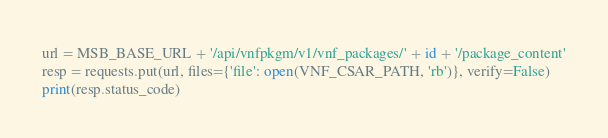Convert code to text. <code><loc_0><loc_0><loc_500><loc_500><_Python_>url = MSB_BASE_URL + '/api/vnfpkgm/v1/vnf_packages/' + id + '/package_content'
resp = requests.put(url, files={'file': open(VNF_CSAR_PATH, 'rb')}, verify=False)
print(resp.status_code)
</code> 